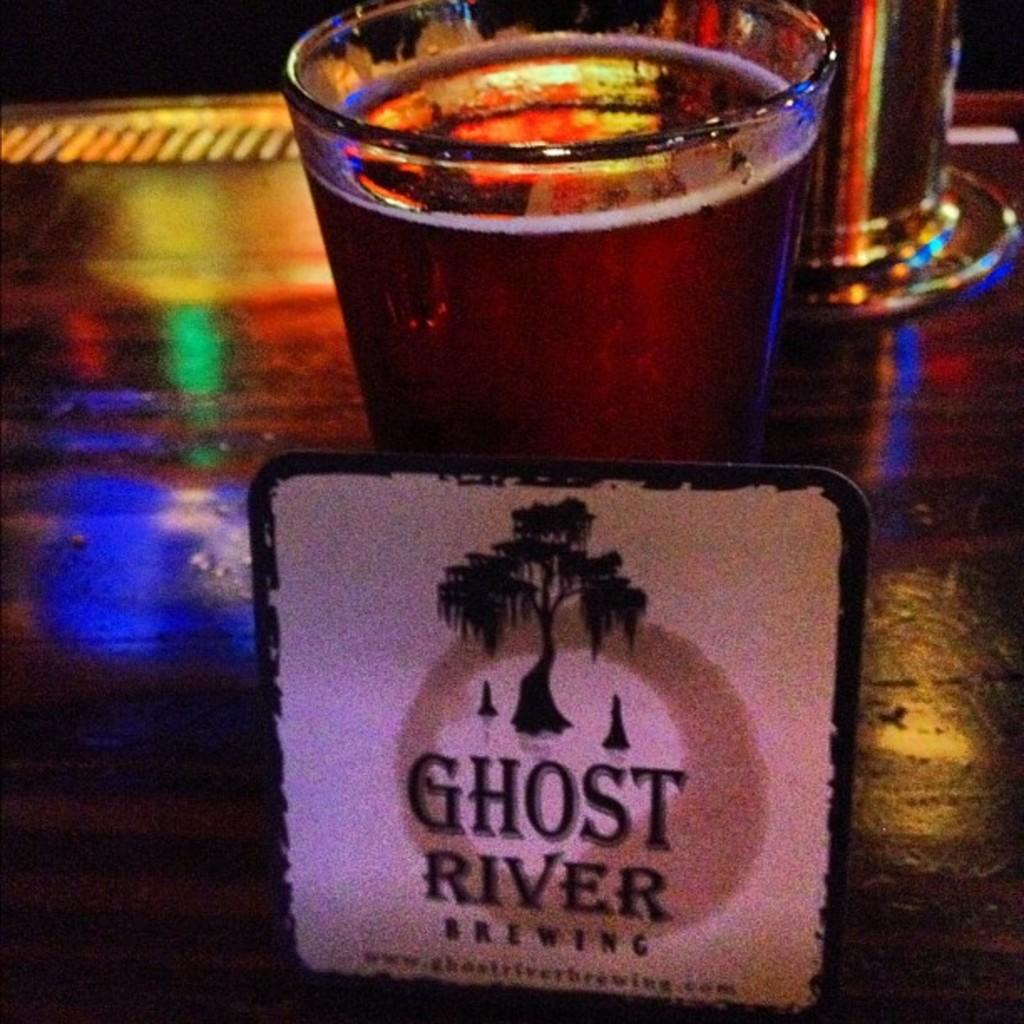<image>
Write a terse but informative summary of the picture. A coaster that reads Ghost River Brewing rested on a glass 